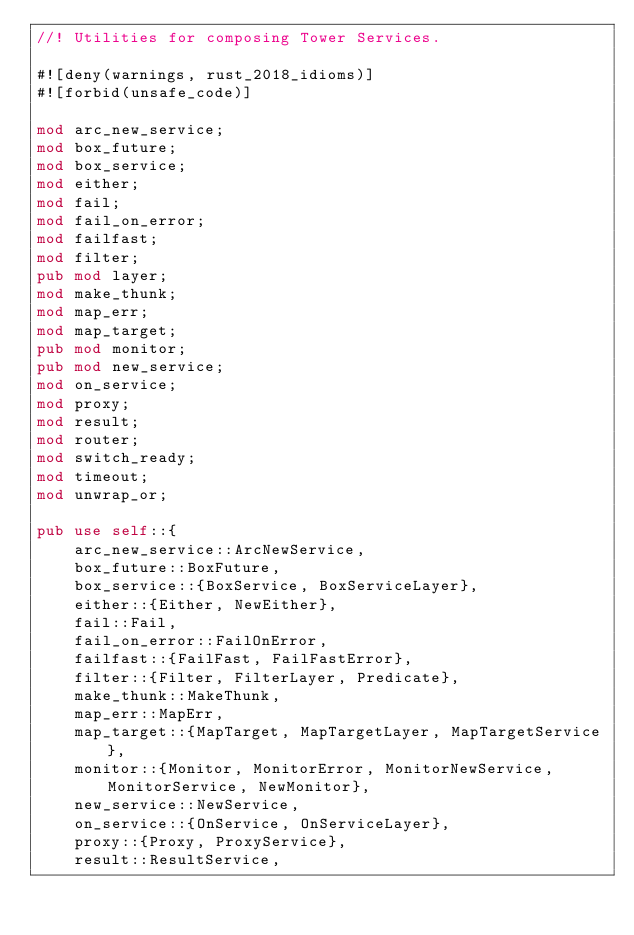Convert code to text. <code><loc_0><loc_0><loc_500><loc_500><_Rust_>//! Utilities for composing Tower Services.

#![deny(warnings, rust_2018_idioms)]
#![forbid(unsafe_code)]

mod arc_new_service;
mod box_future;
mod box_service;
mod either;
mod fail;
mod fail_on_error;
mod failfast;
mod filter;
pub mod layer;
mod make_thunk;
mod map_err;
mod map_target;
pub mod monitor;
pub mod new_service;
mod on_service;
mod proxy;
mod result;
mod router;
mod switch_ready;
mod timeout;
mod unwrap_or;

pub use self::{
    arc_new_service::ArcNewService,
    box_future::BoxFuture,
    box_service::{BoxService, BoxServiceLayer},
    either::{Either, NewEither},
    fail::Fail,
    fail_on_error::FailOnError,
    failfast::{FailFast, FailFastError},
    filter::{Filter, FilterLayer, Predicate},
    make_thunk::MakeThunk,
    map_err::MapErr,
    map_target::{MapTarget, MapTargetLayer, MapTargetService},
    monitor::{Monitor, MonitorError, MonitorNewService, MonitorService, NewMonitor},
    new_service::NewService,
    on_service::{OnService, OnServiceLayer},
    proxy::{Proxy, ProxyService},
    result::ResultService,</code> 